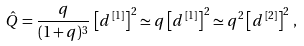<formula> <loc_0><loc_0><loc_500><loc_500>\hat { Q } = \frac { q } { ( 1 + q ) ^ { 3 } } \, \left [ d ^ { \, [ 1 ] } \right ] ^ { 2 } \simeq q \left [ d ^ { \, [ 1 ] } \right ] ^ { 2 } \simeq q ^ { 2 } \left [ d ^ { \, [ 2 ] } \right ] ^ { 2 } \, ,</formula> 